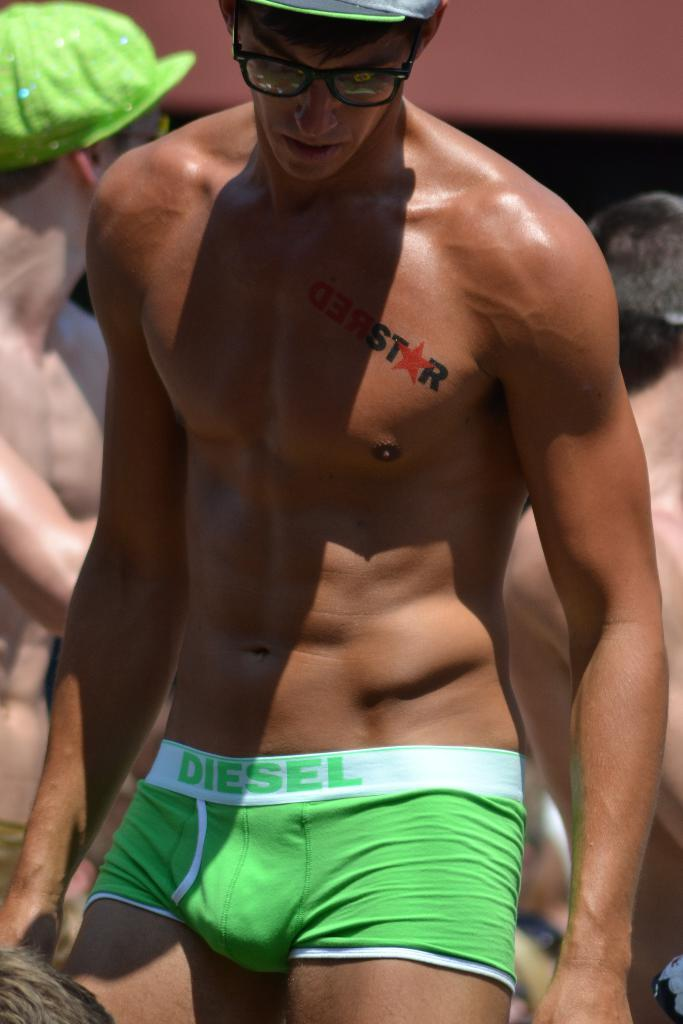<image>
Provide a brief description of the given image. A man wears green Diesel underwear and has a tattoo that reads redstar on his chest. 